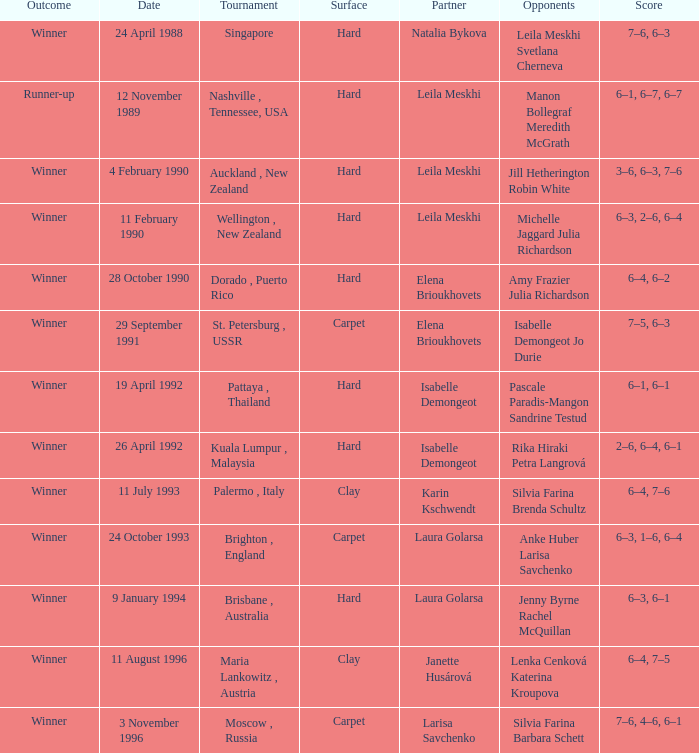Who was the Partner in a game with the Score of 6–4, 6–2 on a hard surface? Elena Brioukhovets. 